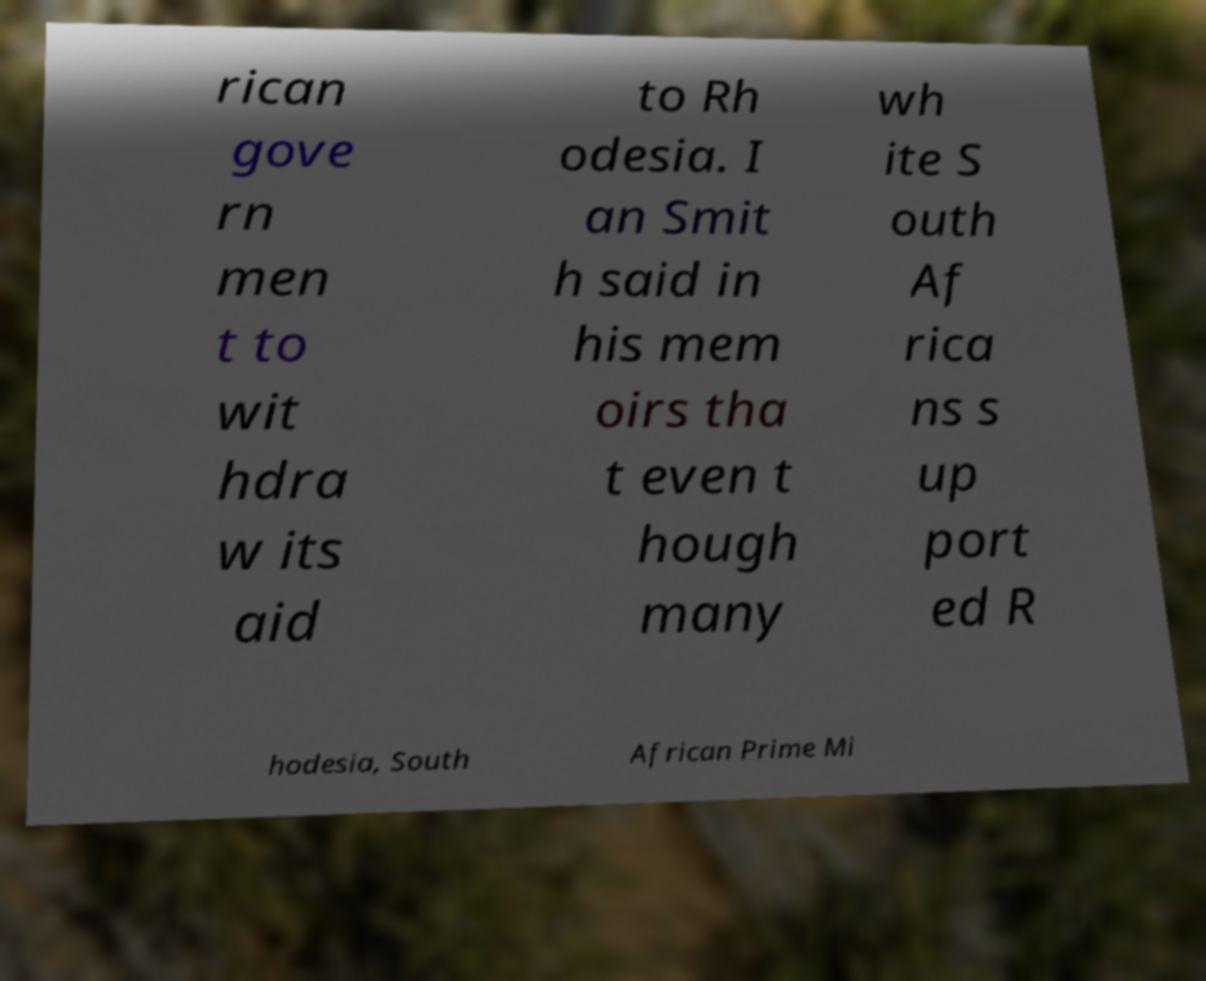Can you accurately transcribe the text from the provided image for me? rican gove rn men t to wit hdra w its aid to Rh odesia. I an Smit h said in his mem oirs tha t even t hough many wh ite S outh Af rica ns s up port ed R hodesia, South African Prime Mi 